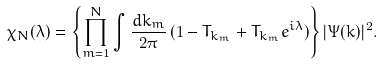Convert formula to latex. <formula><loc_0><loc_0><loc_500><loc_500>\chi _ { N } ( \lambda ) = \left \{ \prod _ { m = 1 } ^ { N } \int \frac { d k _ { m } } { 2 \pi } \, ( 1 - T _ { k _ { m } } + T _ { k _ { m } } e ^ { i \lambda } ) \right \} | \Psi ( k ) | ^ { 2 } .</formula> 